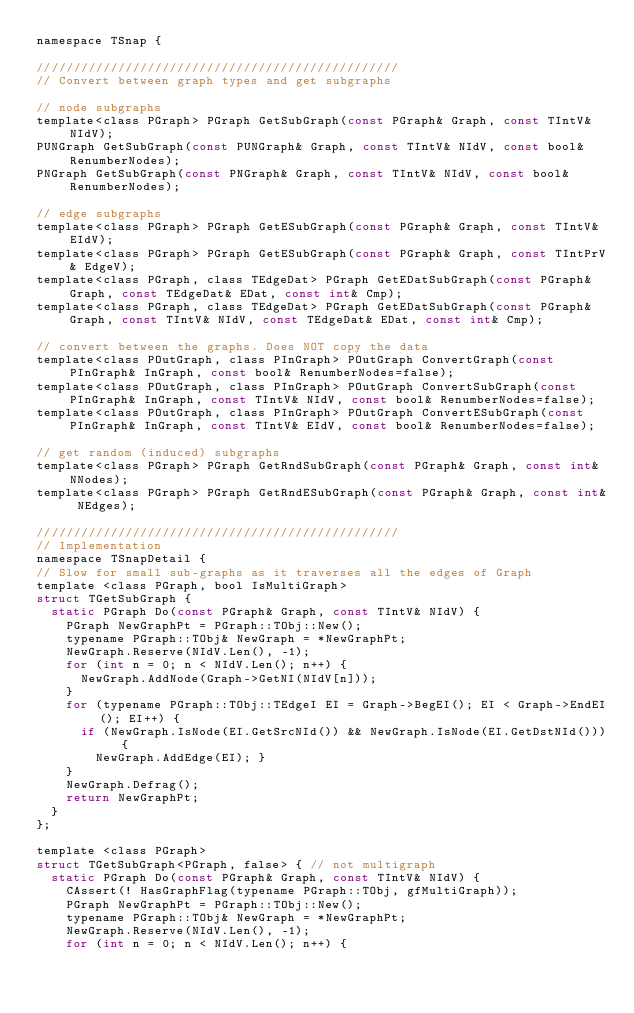Convert code to text. <code><loc_0><loc_0><loc_500><loc_500><_C_>namespace TSnap {

/////////////////////////////////////////////////
// Convert between graph types and get subgraphs

// node subgraphs
template<class PGraph> PGraph GetSubGraph(const PGraph& Graph, const TIntV& NIdV);
PUNGraph GetSubGraph(const PUNGraph& Graph, const TIntV& NIdV, const bool& RenumberNodes);
PNGraph GetSubGraph(const PNGraph& Graph, const TIntV& NIdV, const bool& RenumberNodes);

// edge subgraphs
template<class PGraph> PGraph GetESubGraph(const PGraph& Graph, const TIntV& EIdV);
template<class PGraph> PGraph GetESubGraph(const PGraph& Graph, const TIntPrV& EdgeV);
template<class PGraph, class TEdgeDat> PGraph GetEDatSubGraph(const PGraph& Graph, const TEdgeDat& EDat, const int& Cmp);
template<class PGraph, class TEdgeDat> PGraph GetEDatSubGraph(const PGraph& Graph, const TIntV& NIdV, const TEdgeDat& EDat, const int& Cmp);

// convert between the graphs. Does NOT copy the data
template<class POutGraph, class PInGraph> POutGraph ConvertGraph(const PInGraph& InGraph, const bool& RenumberNodes=false);
template<class POutGraph, class PInGraph> POutGraph ConvertSubGraph(const PInGraph& InGraph, const TIntV& NIdV, const bool& RenumberNodes=false);
template<class POutGraph, class PInGraph> POutGraph ConvertESubGraph(const PInGraph& InGraph, const TIntV& EIdV, const bool& RenumberNodes=false);

// get random (induced) subgraphs 
template<class PGraph> PGraph GetRndSubGraph(const PGraph& Graph, const int& NNodes);
template<class PGraph> PGraph GetRndESubGraph(const PGraph& Graph, const int& NEdges);

/////////////////////////////////////////////////
// Implementation
namespace TSnapDetail {
// Slow for small sub-graphs as it traverses all the edges of Graph
template <class PGraph, bool IsMultiGraph>
struct TGetSubGraph {
  static PGraph Do(const PGraph& Graph, const TIntV& NIdV) {
    PGraph NewGraphPt = PGraph::TObj::New();
    typename PGraph::TObj& NewGraph = *NewGraphPt;
    NewGraph.Reserve(NIdV.Len(), -1);
    for (int n = 0; n < NIdV.Len(); n++) {
      NewGraph.AddNode(Graph->GetNI(NIdV[n])); 
    }
    for (typename PGraph::TObj::TEdgeI EI = Graph->BegEI(); EI < Graph->EndEI(); EI++) {
      if (NewGraph.IsNode(EI.GetSrcNId()) && NewGraph.IsNode(EI.GetDstNId())) {
        NewGraph.AddEdge(EI); }
    }
    NewGraph.Defrag();
    return NewGraphPt;
  }
};

template <class PGraph> 
struct TGetSubGraph<PGraph, false> { // not multigraph
  static PGraph Do(const PGraph& Graph, const TIntV& NIdV) {
    CAssert(! HasGraphFlag(typename PGraph::TObj, gfMultiGraph));
    PGraph NewGraphPt = PGraph::TObj::New();
    typename PGraph::TObj& NewGraph = *NewGraphPt;
    NewGraph.Reserve(NIdV.Len(), -1);
    for (int n = 0; n < NIdV.Len(); n++) {</code> 